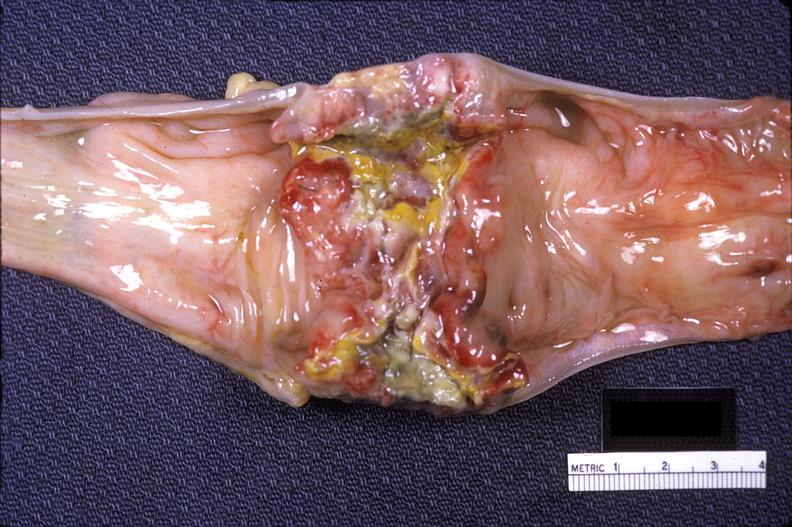does stillborn macerated show colon sigmoid, adenocarcinoma, annular?
Answer the question using a single word or phrase. No 